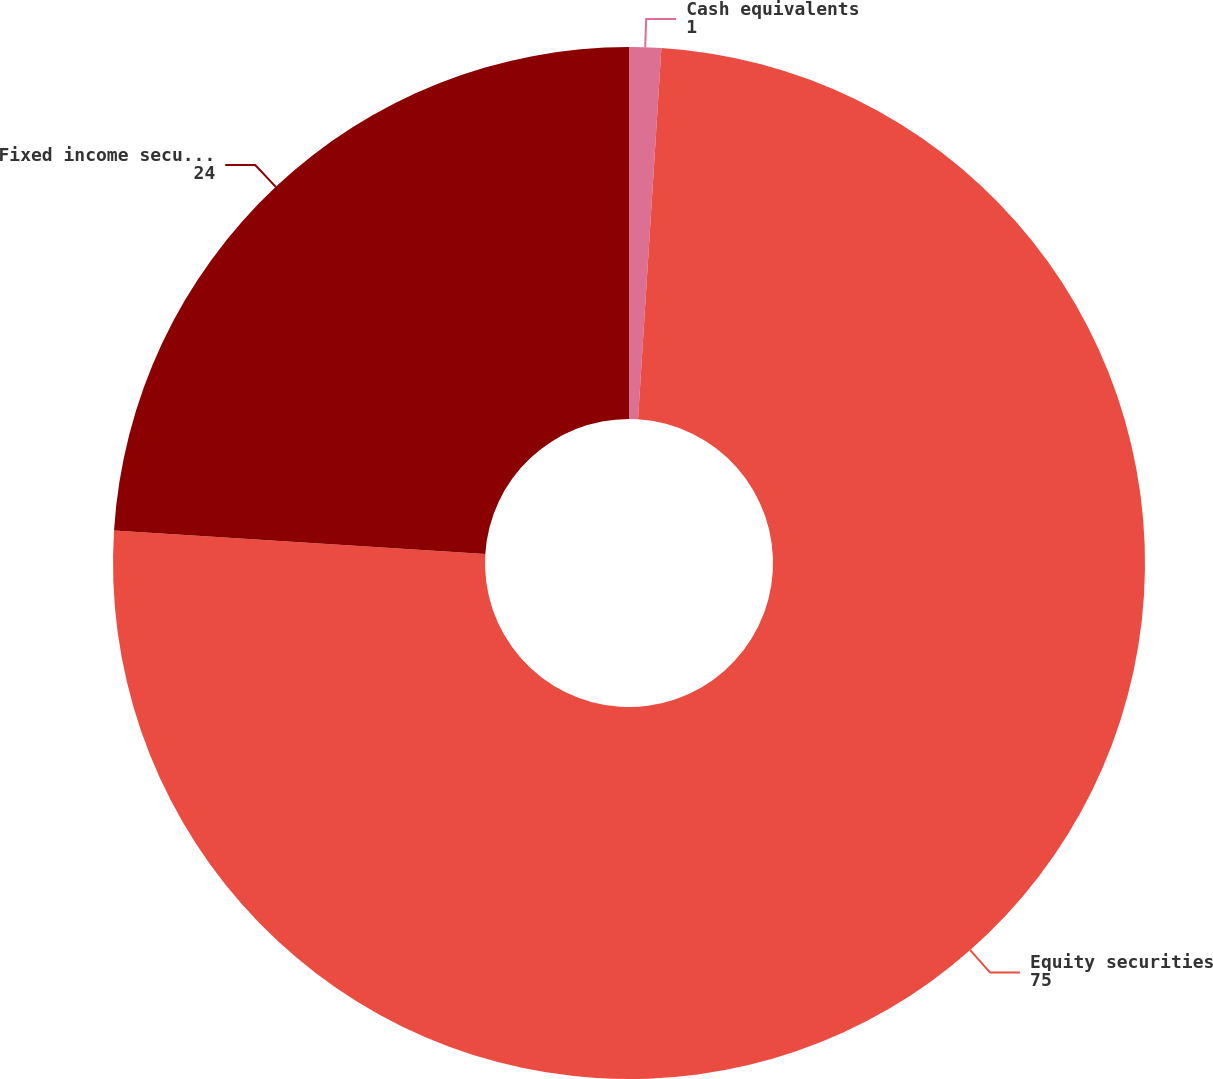Convert chart to OTSL. <chart><loc_0><loc_0><loc_500><loc_500><pie_chart><fcel>Cash equivalents<fcel>Equity securities<fcel>Fixed income securities<nl><fcel>1.0%<fcel>75.0%<fcel>24.0%<nl></chart> 